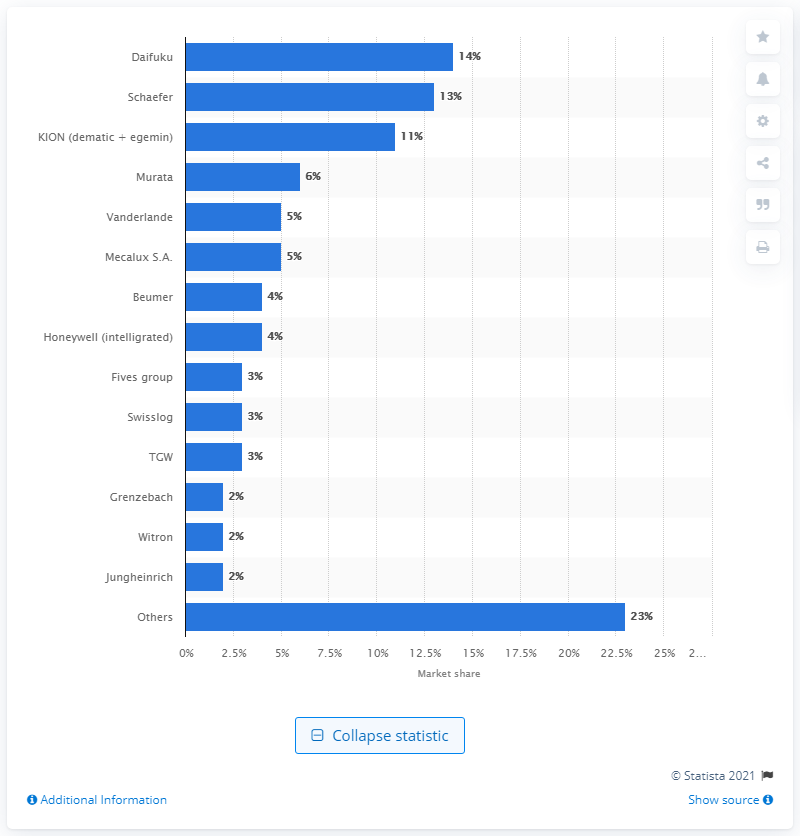Highlight a few significant elements in this photo. Daifuku is the market leader in the warehouse automation market. 